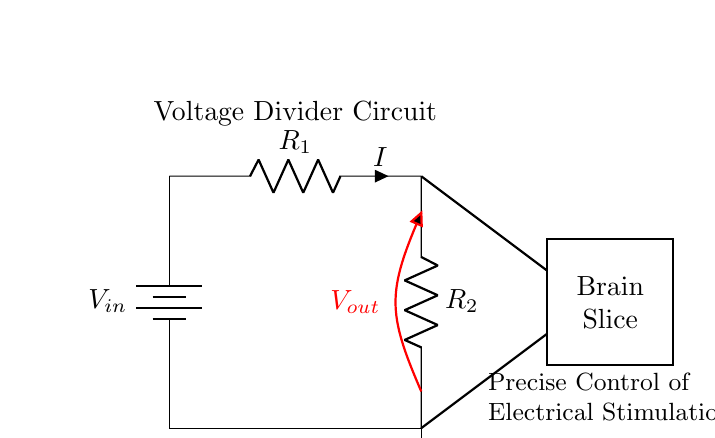What are the two resistors in the circuit? The two resistors in the circuit are denoted as R1 and R2, which are connected in series to form a voltage divider.
Answer: R1 and R2 What is the purpose of the voltage divider circuit? The voltage divider circuit is used to control the output voltage which is applied to the brain slice, thereby allowing precise control of electrical stimulation.
Answer: Precise control of electrical stimulation What is the output voltage denoted as in the circuit? The output voltage is denoted as Vout in the diagram, which is the voltage that results from the division of the input voltage across R1 and R2.
Answer: Vout What happens to the current in the circuit? The current I through the circuit flows continuously through R1 and R2, and is the same across both resistors since they are in series.
Answer: It flows continuously How does changing R1 or R2 affect the output voltage? Changing the values of R1 or R2 alters the ratio of the resistors, which directly affects the division of voltage and thus changes the output voltage Vout, as defined by the formula Vout = Vin * (R2 / (R1 + R2)).
Answer: It alters the output voltage What is represented by the rectangle labeled "Brain Slice"? The rectangle labeled "Brain Slice" represents the part of the circuit where electrical stimulation is applied, simulating a biological environment for experimental purposes.
Answer: Electrical stimulation What is the significance of the thick red line in the circuit? The thick red line represents Vout, indicating the point at which the output voltage is taken from the circuit for stimulation purposes.
Answer: It indicates Vout 